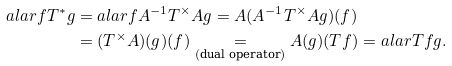<formula> <loc_0><loc_0><loc_500><loc_500>a l a r { f } { T ^ { * } g } & = a l a r { f } { A ^ { - 1 } T ^ { \times } A g } = A ( A ^ { - 1 } T ^ { \times } A g ) ( f ) \\ & = ( T ^ { \times } A ) ( g ) ( f ) \underset { ( \text {dual operator} ) } { = } A ( g ) ( T f ) = a l a r { T f } { g } .</formula> 